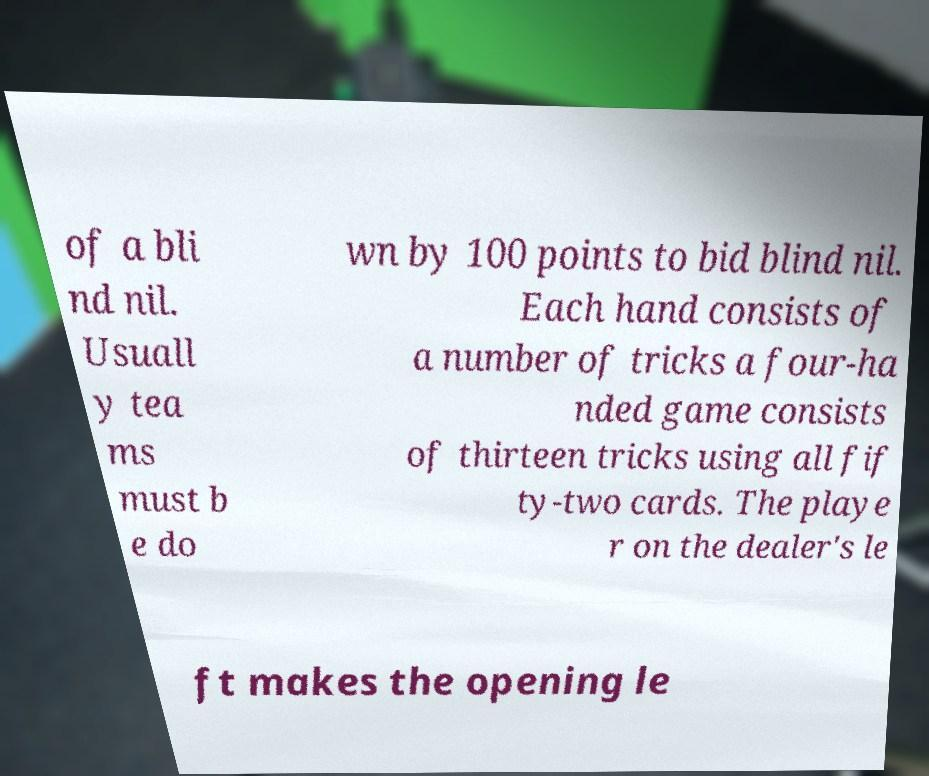Please read and relay the text visible in this image. What does it say? of a bli nd nil. Usuall y tea ms must b e do wn by 100 points to bid blind nil. Each hand consists of a number of tricks a four-ha nded game consists of thirteen tricks using all fif ty-two cards. The playe r on the dealer's le ft makes the opening le 